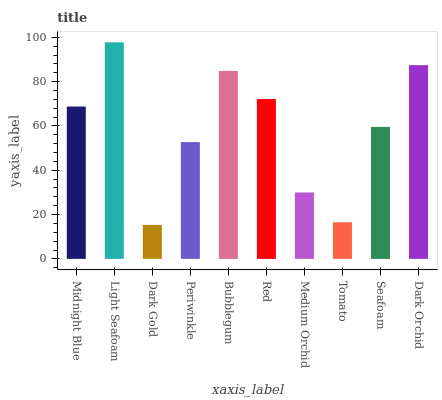Is Dark Gold the minimum?
Answer yes or no. Yes. Is Light Seafoam the maximum?
Answer yes or no. Yes. Is Light Seafoam the minimum?
Answer yes or no. No. Is Dark Gold the maximum?
Answer yes or no. No. Is Light Seafoam greater than Dark Gold?
Answer yes or no. Yes. Is Dark Gold less than Light Seafoam?
Answer yes or no. Yes. Is Dark Gold greater than Light Seafoam?
Answer yes or no. No. Is Light Seafoam less than Dark Gold?
Answer yes or no. No. Is Midnight Blue the high median?
Answer yes or no. Yes. Is Seafoam the low median?
Answer yes or no. Yes. Is Red the high median?
Answer yes or no. No. Is Dark Gold the low median?
Answer yes or no. No. 